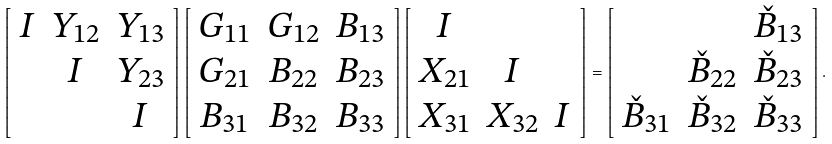<formula> <loc_0><loc_0><loc_500><loc_500>\left [ \begin{array} { c c c } I & Y _ { 1 2 } & Y _ { 1 3 } \\ & I & Y _ { 2 3 } \\ & & I \end{array} \right ] \left [ \begin{array} { c c c } G _ { 1 1 } & G _ { 1 2 } & B _ { 1 3 } \\ G _ { 2 1 } & B _ { 2 2 } & B _ { 2 3 } \\ B _ { 3 1 } & B _ { 3 2 } & B _ { 3 3 } \end{array} \right ] \left [ \begin{array} { c c c } I & & \\ X _ { 2 1 } & I & \\ X _ { 3 1 } & X _ { 3 2 } & I \end{array} \right ] = \left [ \begin{array} { c c c } & & \check { B } _ { 1 3 } \\ & \check { B } _ { 2 2 } & \check { B } _ { 2 3 } \\ \check { B } _ { 3 1 } & \check { B } _ { 3 2 } & \check { B } _ { 3 3 } \end{array} \right ] .</formula> 